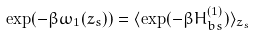<formula> <loc_0><loc_0><loc_500><loc_500>\exp ( - \beta \omega _ { 1 } ( z _ { s } ) ) = \langle \exp ( - \beta H _ { b s } ^ { ( 1 ) } ) \rangle _ { z _ { s } }</formula> 